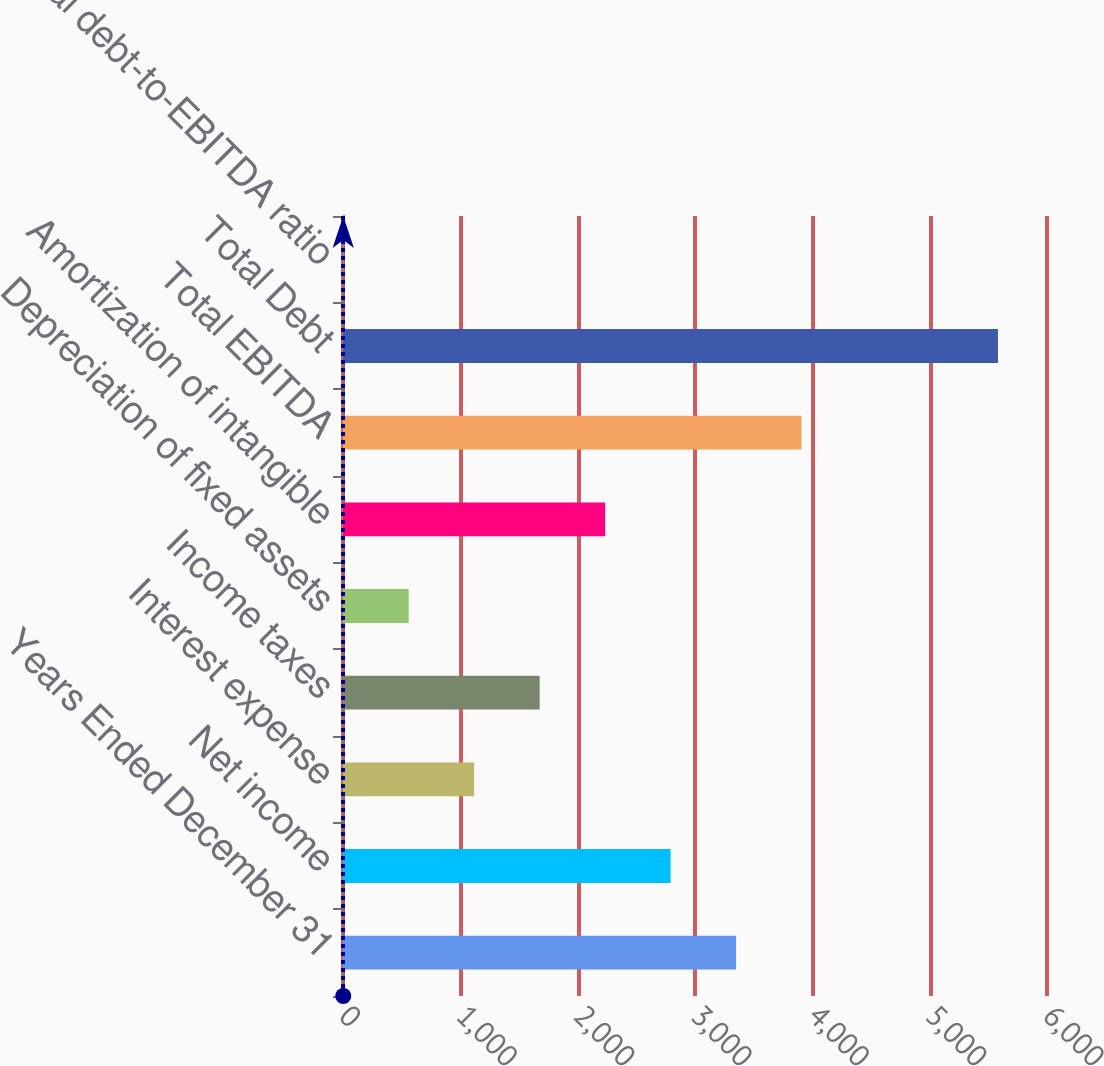Convert chart. <chart><loc_0><loc_0><loc_500><loc_500><bar_chart><fcel>Years Ended December 31<fcel>Net income<fcel>Interest expense<fcel>Income taxes<fcel>Depreciation of fixed assets<fcel>Amortization of intangible<fcel>Total EBITDA<fcel>Total Debt<fcel>Total debt-to-EBITDA ratio<nl><fcel>3350.04<fcel>2792.05<fcel>1118.08<fcel>1676.07<fcel>560.09<fcel>2234.06<fcel>3908.03<fcel>5582<fcel>2.1<nl></chart> 